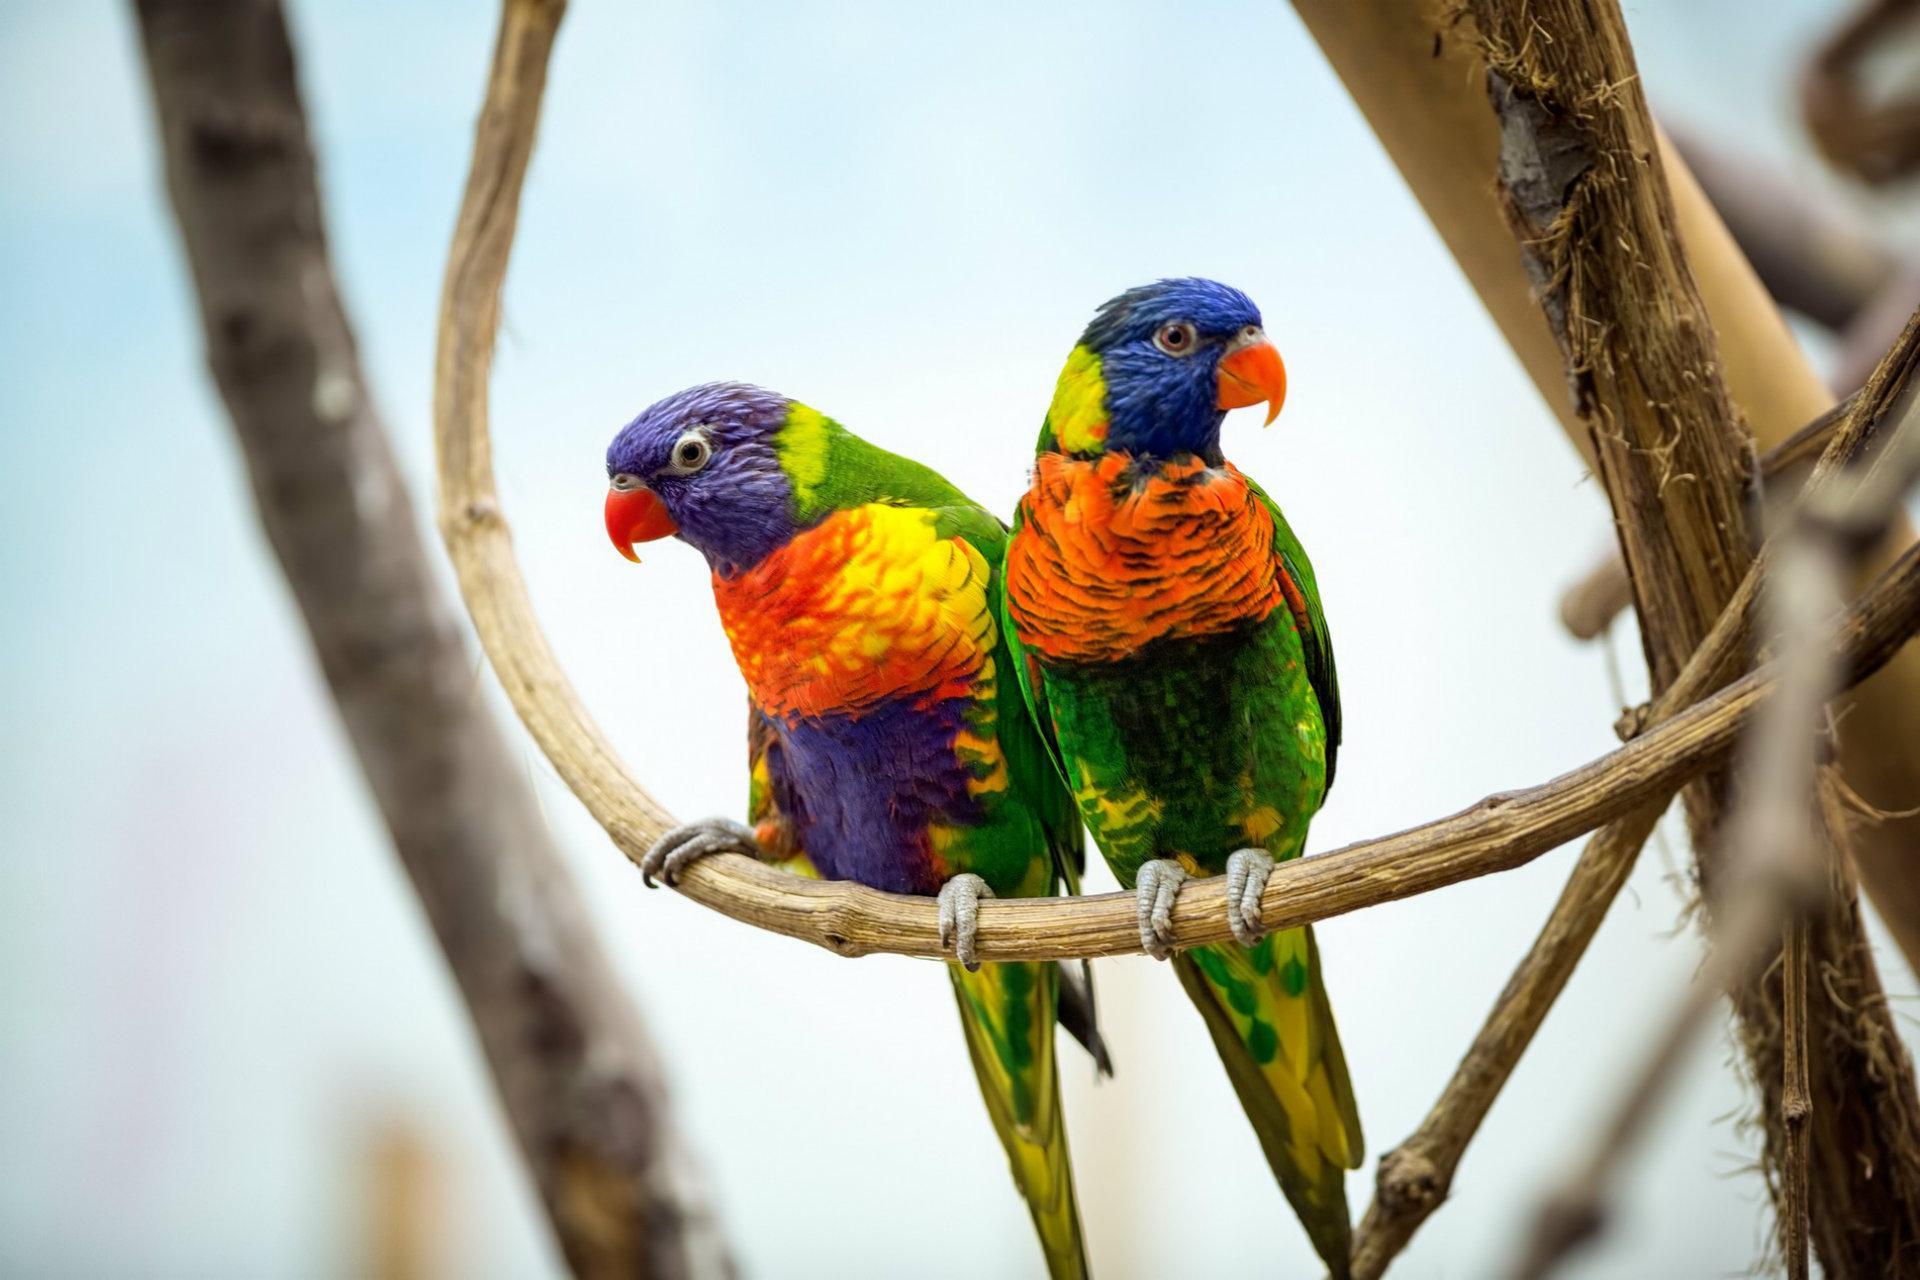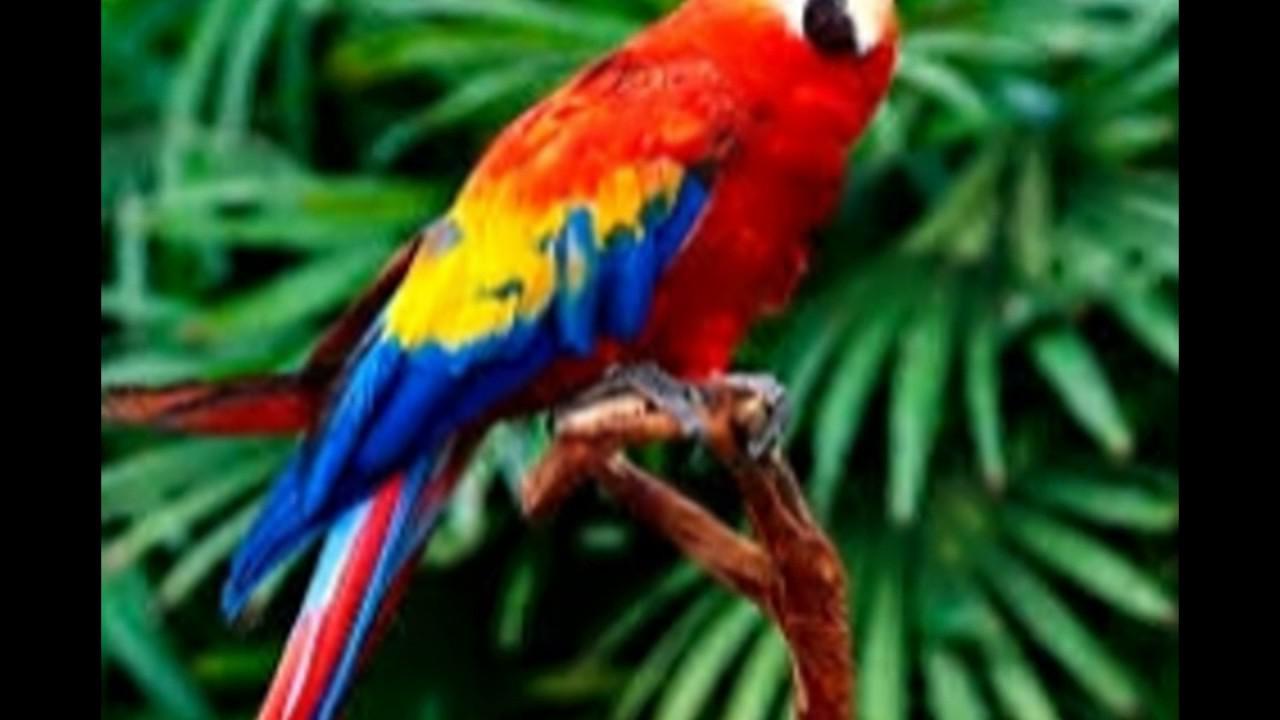The first image is the image on the left, the second image is the image on the right. Assess this claim about the two images: "In one of the images, the birds are only shown as profile.". Correct or not? Answer yes or no. No. The first image is the image on the left, the second image is the image on the right. Evaluate the accuracy of this statement regarding the images: "The parrot furthest on the left is facing in the left direction.". Is it true? Answer yes or no. Yes. 